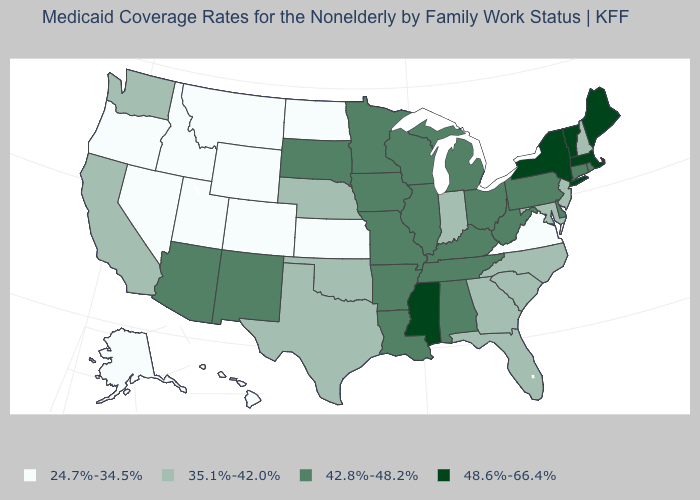Which states have the lowest value in the USA?
Keep it brief. Alaska, Colorado, Hawaii, Idaho, Kansas, Montana, Nevada, North Dakota, Oregon, Utah, Virginia, Wyoming. Among the states that border Arizona , which have the highest value?
Be succinct. New Mexico. Which states have the lowest value in the USA?
Concise answer only. Alaska, Colorado, Hawaii, Idaho, Kansas, Montana, Nevada, North Dakota, Oregon, Utah, Virginia, Wyoming. Name the states that have a value in the range 24.7%-34.5%?
Write a very short answer. Alaska, Colorado, Hawaii, Idaho, Kansas, Montana, Nevada, North Dakota, Oregon, Utah, Virginia, Wyoming. What is the value of Arkansas?
Give a very brief answer. 42.8%-48.2%. What is the value of New Hampshire?
Short answer required. 35.1%-42.0%. What is the value of Arkansas?
Quick response, please. 42.8%-48.2%. Does Arizona have a lower value than Massachusetts?
Give a very brief answer. Yes. Among the states that border Washington , which have the highest value?
Write a very short answer. Idaho, Oregon. What is the highest value in the Northeast ?
Give a very brief answer. 48.6%-66.4%. Which states have the highest value in the USA?
Keep it brief. Maine, Massachusetts, Mississippi, New York, Vermont. What is the value of Maine?
Give a very brief answer. 48.6%-66.4%. Which states have the highest value in the USA?
Quick response, please. Maine, Massachusetts, Mississippi, New York, Vermont. Does Tennessee have the lowest value in the South?
Concise answer only. No. Name the states that have a value in the range 24.7%-34.5%?
Answer briefly. Alaska, Colorado, Hawaii, Idaho, Kansas, Montana, Nevada, North Dakota, Oregon, Utah, Virginia, Wyoming. 